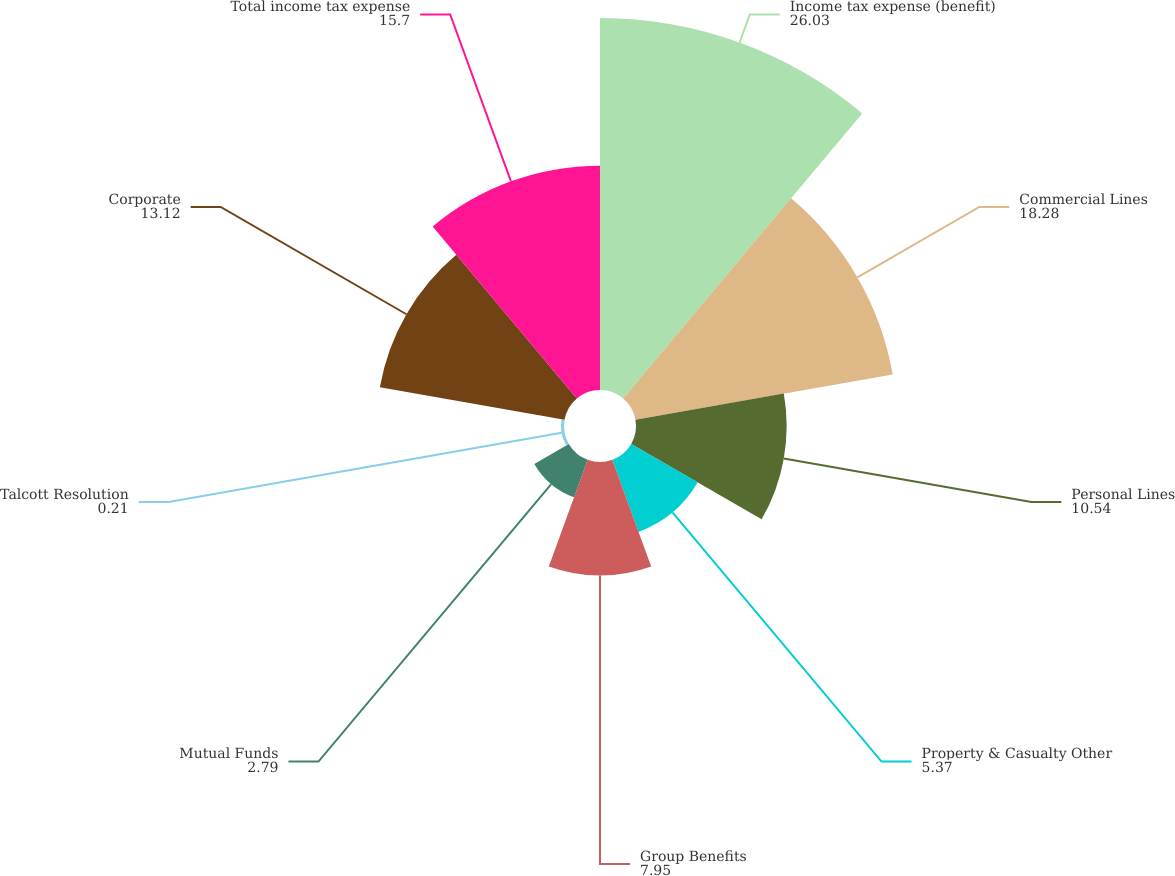<chart> <loc_0><loc_0><loc_500><loc_500><pie_chart><fcel>Income tax expense (benefit)<fcel>Commercial Lines<fcel>Personal Lines<fcel>Property & Casualty Other<fcel>Group Benefits<fcel>Mutual Funds<fcel>Talcott Resolution<fcel>Corporate<fcel>Total income tax expense<nl><fcel>26.03%<fcel>18.28%<fcel>10.54%<fcel>5.37%<fcel>7.95%<fcel>2.79%<fcel>0.21%<fcel>13.12%<fcel>15.7%<nl></chart> 